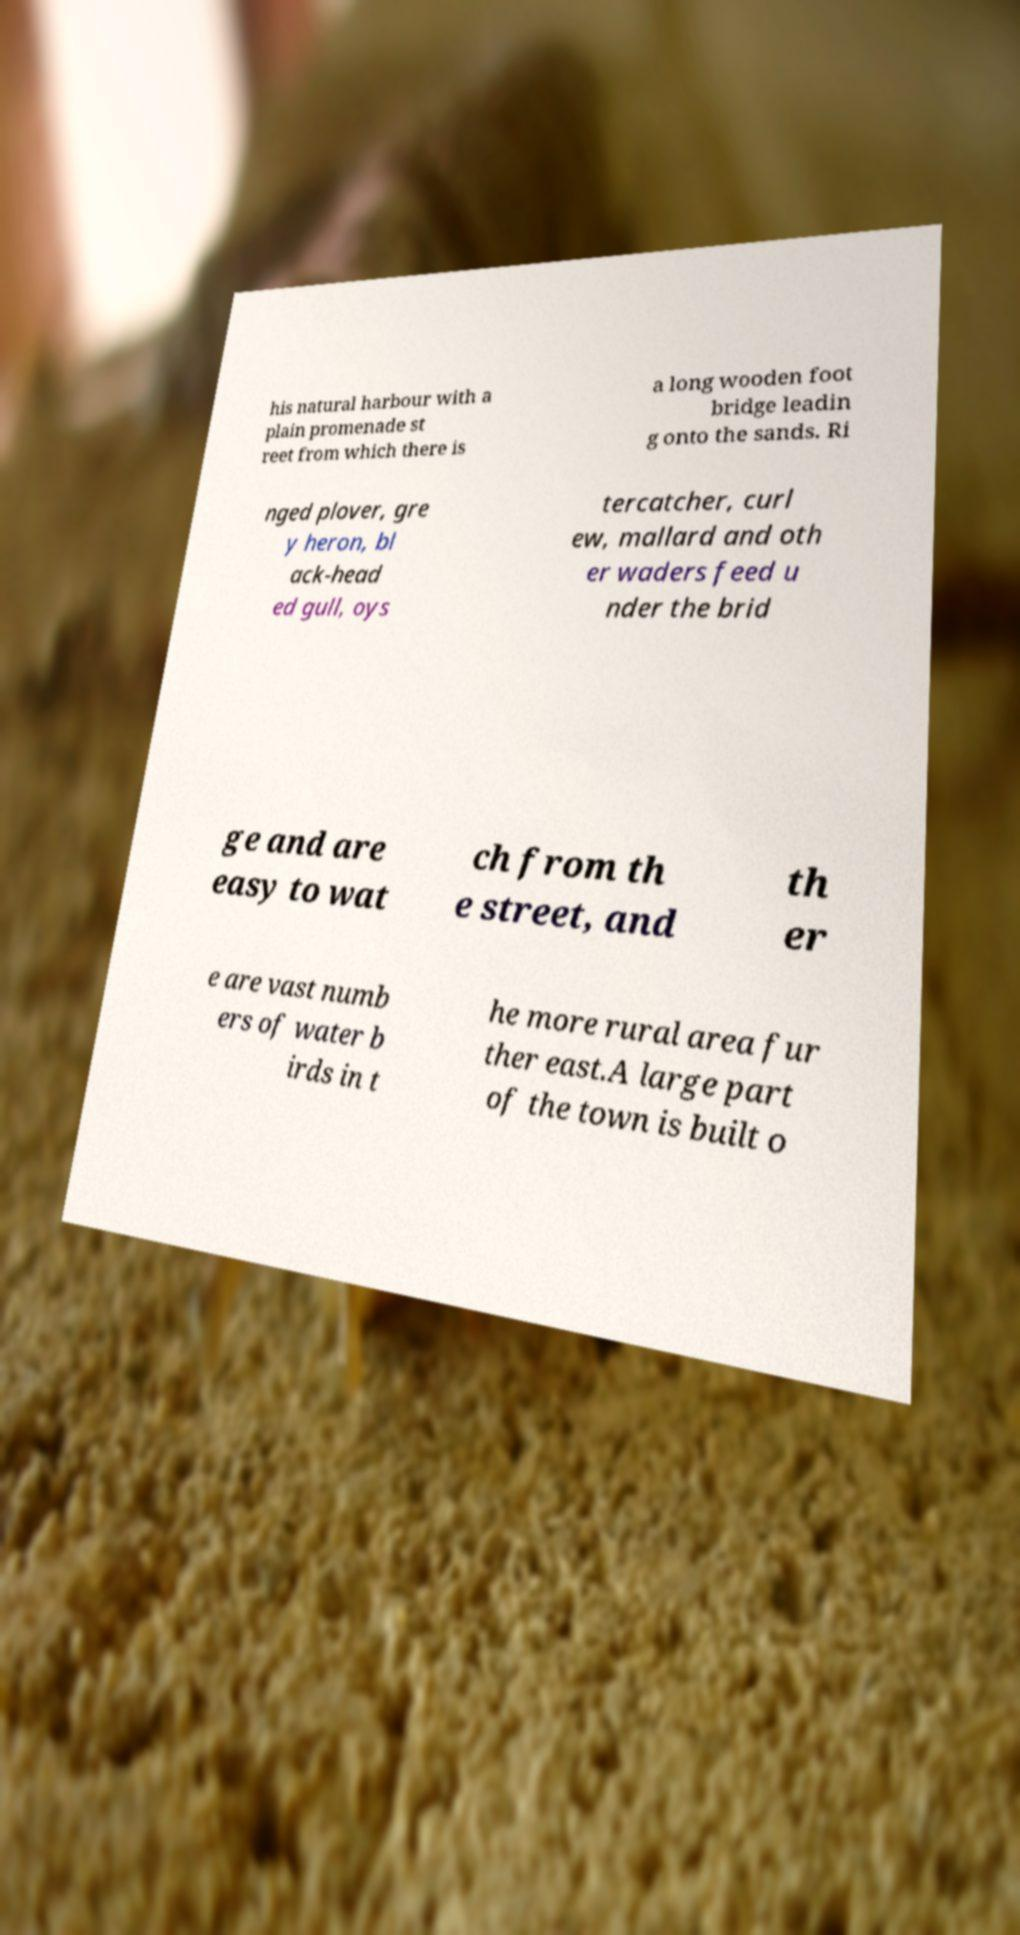Please identify and transcribe the text found in this image. his natural harbour with a plain promenade st reet from which there is a long wooden foot bridge leadin g onto the sands. Ri nged plover, gre y heron, bl ack-head ed gull, oys tercatcher, curl ew, mallard and oth er waders feed u nder the brid ge and are easy to wat ch from th e street, and th er e are vast numb ers of water b irds in t he more rural area fur ther east.A large part of the town is built o 